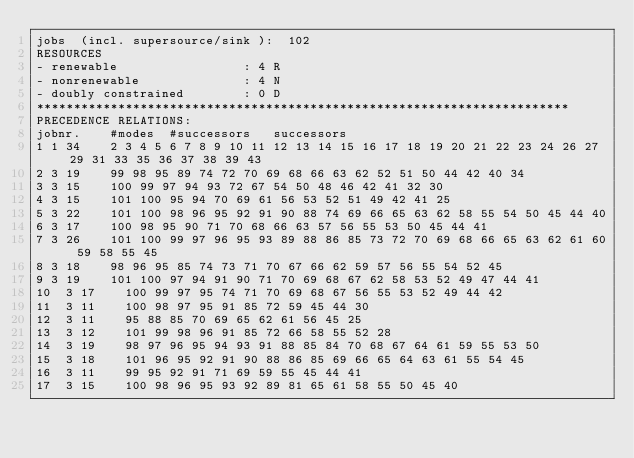<code> <loc_0><loc_0><loc_500><loc_500><_ObjectiveC_>jobs  (incl. supersource/sink ):	102
RESOURCES
- renewable                 : 4 R
- nonrenewable              : 4 N
- doubly constrained        : 0 D
************************************************************************
PRECEDENCE RELATIONS:
jobnr.    #modes  #successors   successors
1	1	34		2 3 4 5 6 7 8 9 10 11 12 13 14 15 16 17 18 19 20 21 22 23 24 26 27 29 31 33 35 36 37 38 39 43 
2	3	19		99 98 95 89 74 72 70 69 68 66 63 62 52 51 50 44 42 40 34 
3	3	15		100 99 97 94 93 72 67 54 50 48 46 42 41 32 30 
4	3	15		101 100 95 94 70 69 61 56 53 52 51 49 42 41 25 
5	3	22		101 100 98 96 95 92 91 90 88 74 69 66 65 63 62 58 55 54 50 45 44 40 
6	3	17		100 98 95 90 71 70 68 66 63 57 56 55 53 50 45 44 41 
7	3	26		101 100 99 97 96 95 93 89 88 86 85 73 72 70 69 68 66 65 63 62 61 60 59 58 55 45 
8	3	18		98 96 95 85 74 73 71 70 67 66 62 59 57 56 55 54 52 45 
9	3	19		101 100 97 94 91 90 71 70 69 68 67 62 58 53 52 49 47 44 41 
10	3	17		100 99 97 95 74 71 70 69 68 67 56 55 53 52 49 44 42 
11	3	11		100 98 97 95 91 85 72 59 45 44 30 
12	3	11		95 88 85 70 69 65 62 61 56 45 25 
13	3	12		101 99 98 96 91 85 72 66 58 55 52 28 
14	3	19		98 97 96 95 94 93 91 88 85 84 70 68 67 64 61 59 55 53 50 
15	3	18		101 96 95 92 91 90 88 86 85 69 66 65 64 63 61 55 54 45 
16	3	11		99 95 92 91 71 69 59 55 45 44 41 
17	3	15		100 98 96 95 93 92 89 81 65 61 58 55 50 45 40 </code> 